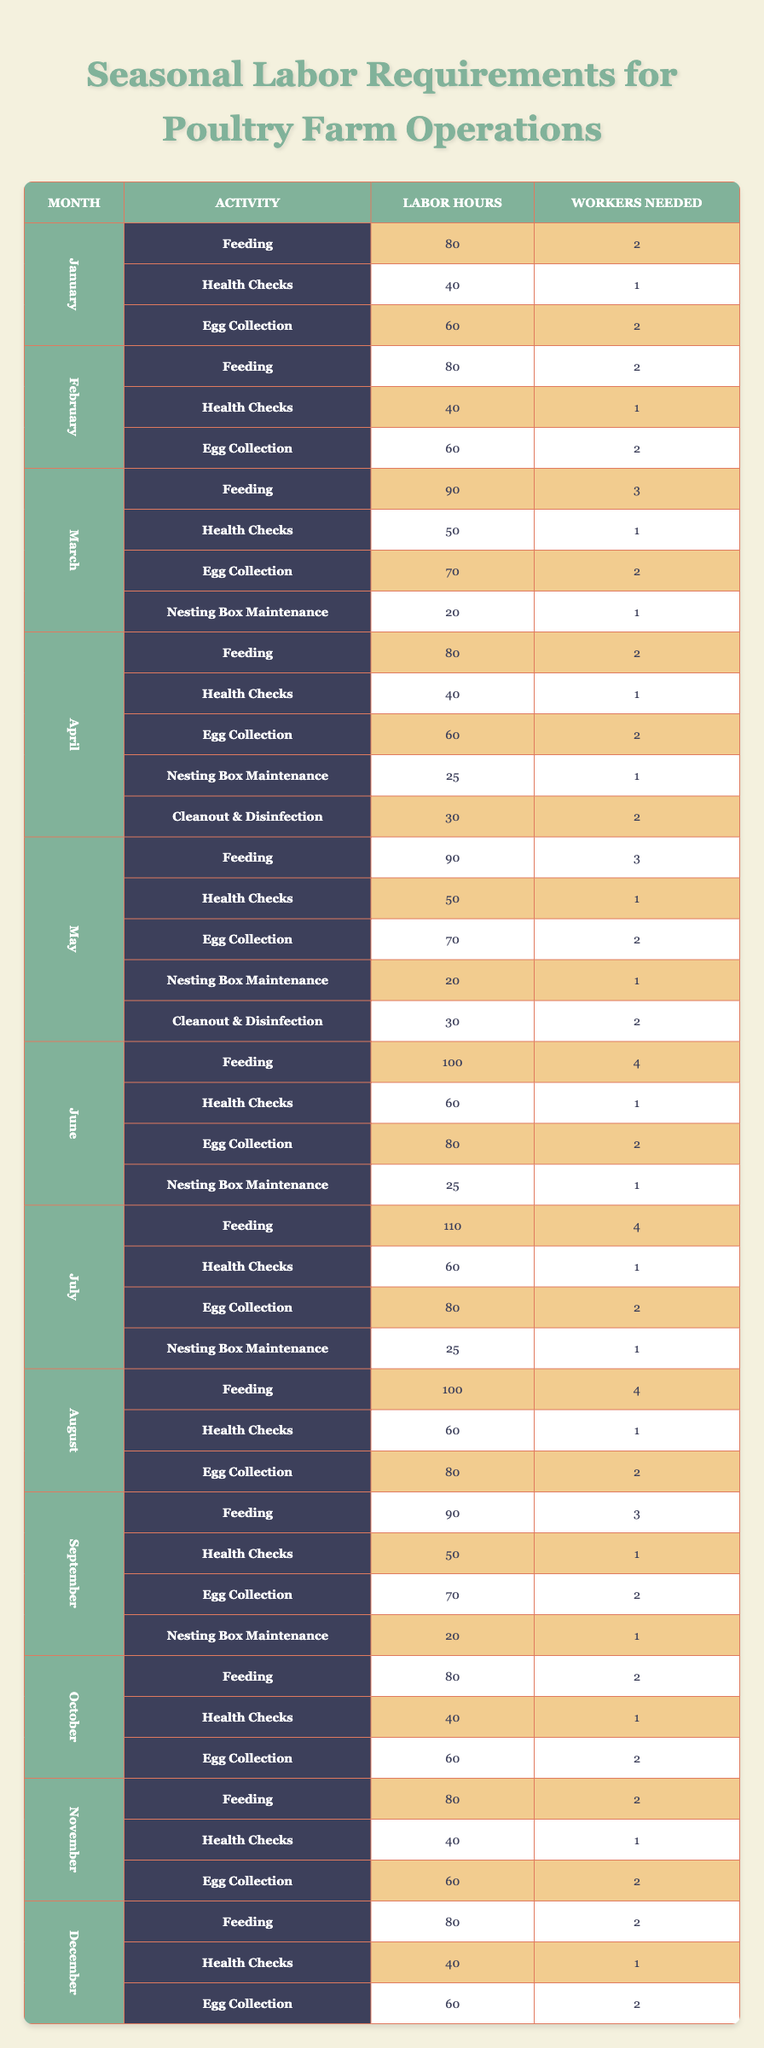What is the total labor hours required for Feeding in June? In June, the labor hours required for Feeding is listed as 100. This is the only activity mentioned for Feeding in that month, so the total labor hours is simply 100.
Answer: 100 How many workers are needed for Egg Collection in March? In March, the table states that 2 workers are needed for Egg Collection. This is a direct lookup from the table, as it is clearly mentioned.
Answer: 2 Does the labor hours for Health Checks remain constant from February to April? In February, the labor hours for Health Checks are 40, while in April, they remain the same at 40. Thus, they do remain constant over these months.
Answer: Yes What is the total number of workers required for all activities in May? For May, the number of workers needed for each activity is as follows: Feeding (3), Health Checks (1), Egg Collection (2), Nesting Box Maintenance (1), and Cleanout & Disinfection (2). Adding these together gives 3 + 1 + 2 + 1 + 2 = 9 workers total.
Answer: 9 Which month requires the most labor hours for Feeding? The data shows that in July, the labor hours required for Feeding is 110. Comparing this with other months, July has the highest number of labor hours for this activity.
Answer: July How do the number of workers for Health Checks in July compare to those in December? In July, the number of workers needed for Health Checks is 1, while in December, it is also 1. Therefore, the number of workers required for Health Checks remains the same in both months.
Answer: Equal What is the average labor hours required for Egg Collection from January to April? The labor hours for Egg Collection from January to April are: January (60), February (60), March (70), and April (60). Summing these gives 60 + 60 + 70 + 60 = 250; then dividing by the number of months (4) gives an average of 250 / 4 = 62.5.
Answer: 62.5 In which month do we find the highest number of workers needed across all activities? Analyzing each month: June (4), July (4), and other months have fewer. Hence, June and July have the highest number of workers required for an activity, both needing 4 workers for Feeding.
Answer: June and July Are there more activities listed in May than in January? In January, there are 3 activities (Feeding, Health Checks, Egg Collection) while in May, there are 5 activities (Feeding, Health Checks, Egg Collection, Nesting Box Maintenance, Cleanout & Disinfection). Therefore, there are indeed more activities in May than in January.
Answer: Yes 